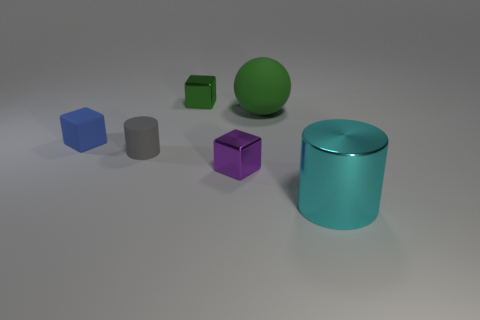Subtract all metallic cubes. How many cubes are left? 1 Add 4 large balls. How many objects exist? 10 Subtract all balls. How many objects are left? 5 Subtract all yellow cubes. Subtract all cyan things. How many objects are left? 5 Add 2 spheres. How many spheres are left? 3 Add 2 big yellow cylinders. How many big yellow cylinders exist? 2 Subtract 1 green spheres. How many objects are left? 5 